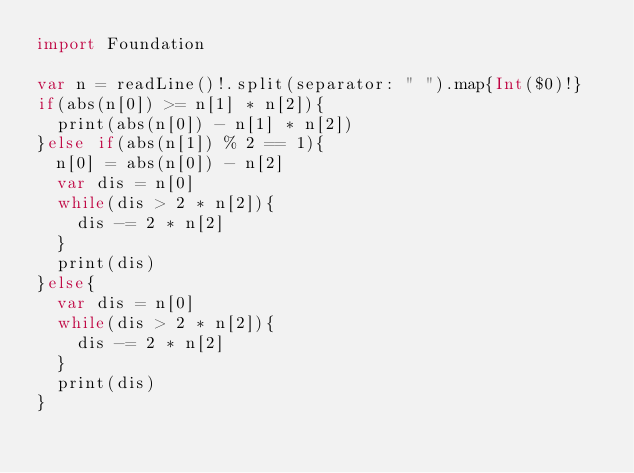Convert code to text. <code><loc_0><loc_0><loc_500><loc_500><_Swift_>import Foundation

var n = readLine()!.split(separator: " ").map{Int($0)!}
if(abs(n[0]) >= n[1] * n[2]){
  print(abs(n[0]) - n[1] * n[2])
}else if(abs(n[1]) % 2 == 1){
  n[0] = abs(n[0]) - n[2]
  var dis = n[0]
  while(dis > 2 * n[2]){
    dis -= 2 * n[2]
  }
  print(dis)
}else{
  var dis = n[0]
  while(dis > 2 * n[2]){
    dis -= 2 * n[2]
  }
  print(dis)
}</code> 